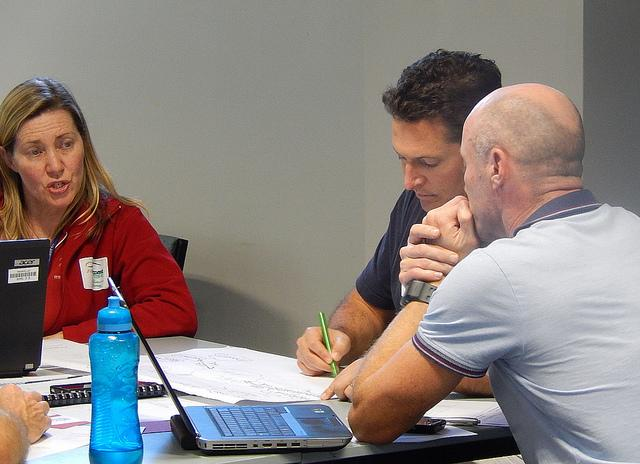The blue bottle is there to satisfy what need?

Choices:
A) elimination
B) thirst
C) medication
D) hunger thirst 